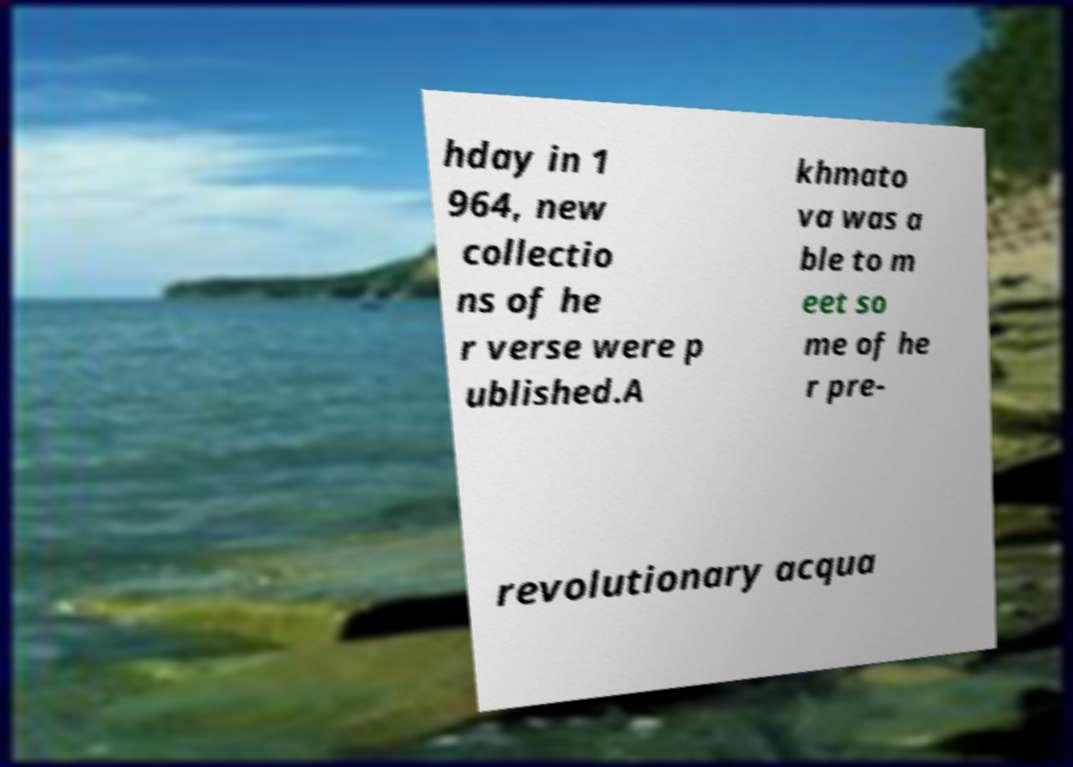Please identify and transcribe the text found in this image. hday in 1 964, new collectio ns of he r verse were p ublished.A khmato va was a ble to m eet so me of he r pre- revolutionary acqua 